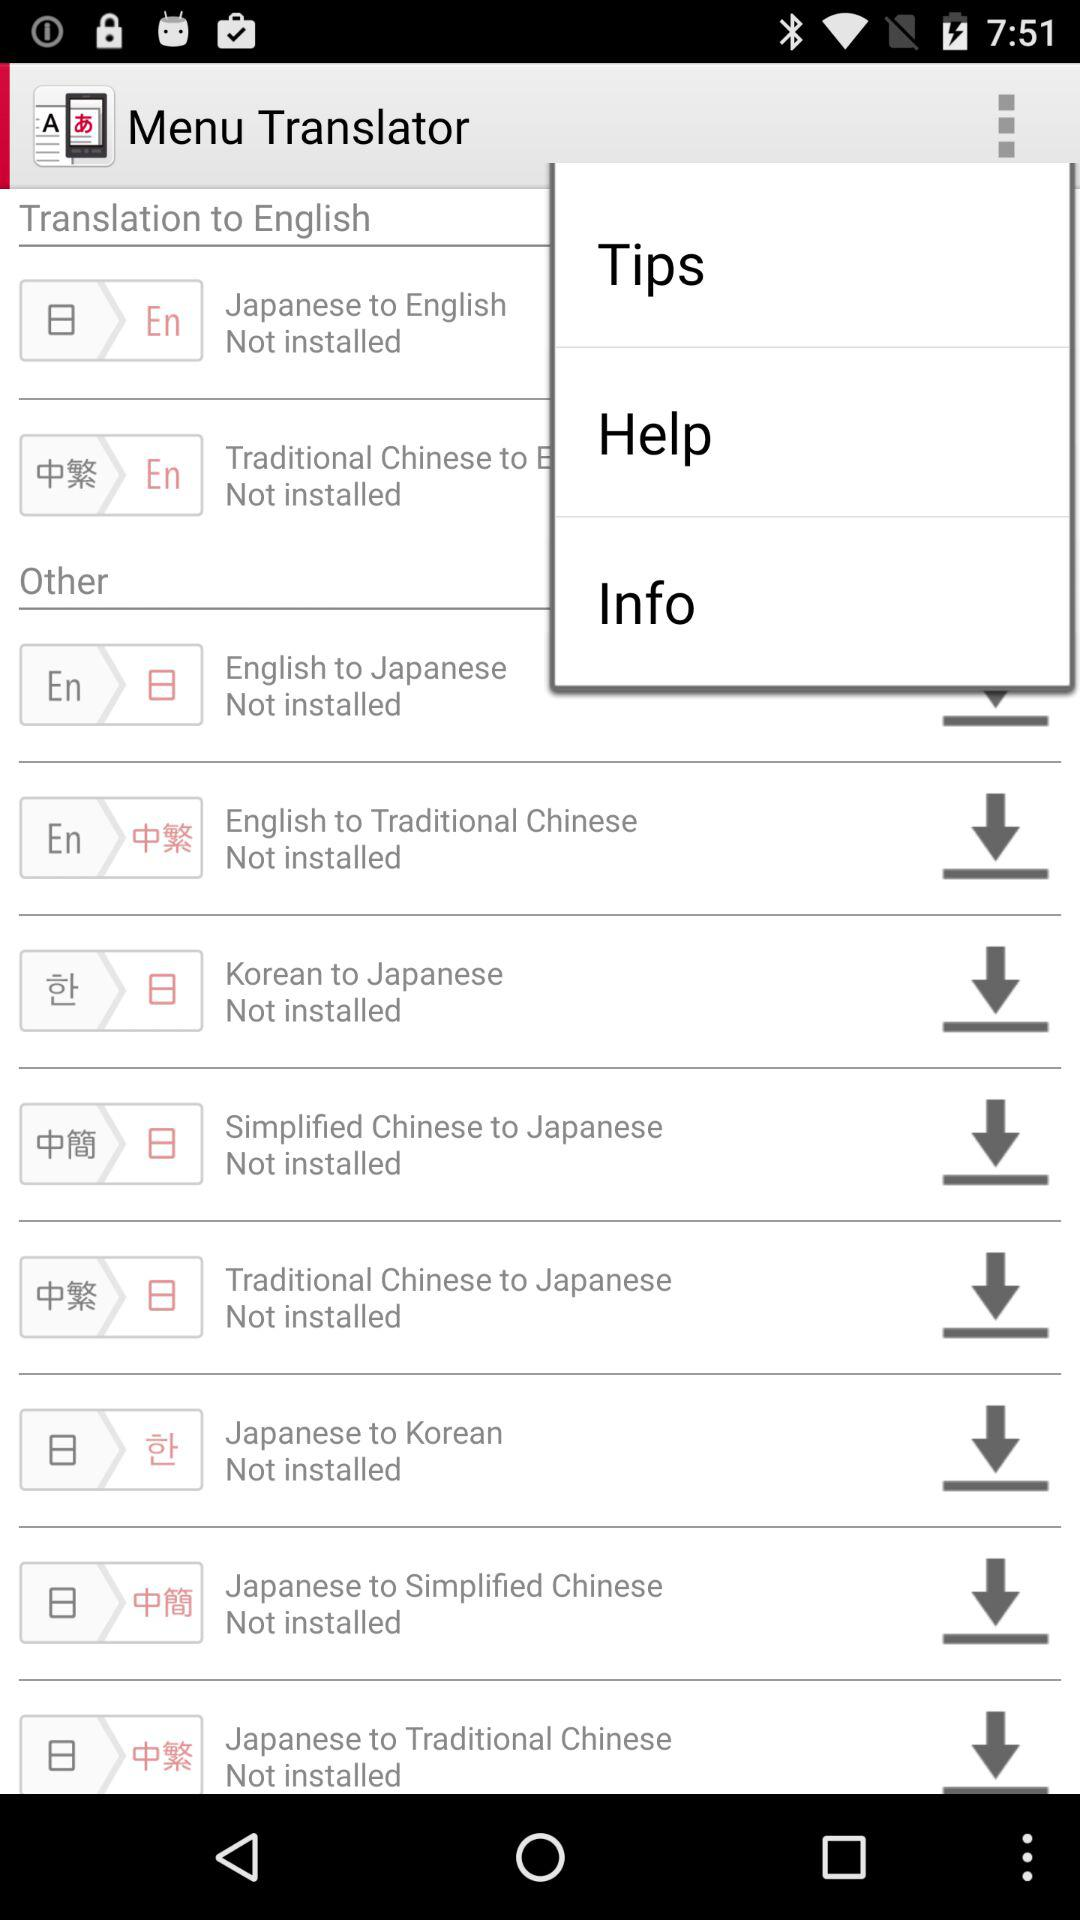What is the name of the application? The name of the application is "Menu Translator". 